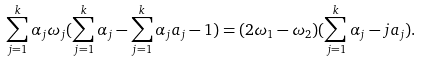Convert formula to latex. <formula><loc_0><loc_0><loc_500><loc_500>\sum _ { j = 1 } ^ { k } \alpha _ { j } \omega _ { j } ( \sum _ { j = 1 } ^ { k } \alpha _ { j } - \sum _ { j = 1 } ^ { k } \alpha _ { j } a _ { j } - 1 ) = ( 2 \omega _ { 1 } - \omega _ { 2 } ) ( \sum _ { j = 1 } ^ { k } \alpha _ { j } - j a _ { j } ) .</formula> 